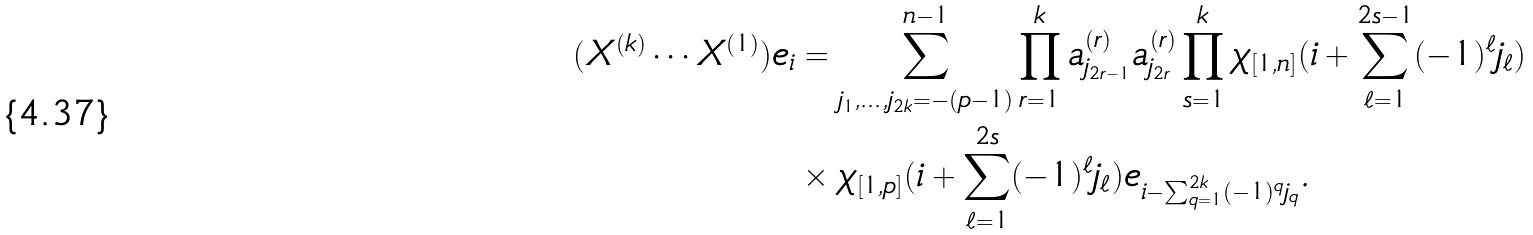<formula> <loc_0><loc_0><loc_500><loc_500>( X ^ { ( k ) } \cdots X ^ { ( 1 ) } ) e _ { i } & = \sum _ { j _ { 1 } , \dots , j _ { 2 k } = - ( p - 1 ) } ^ { n - 1 } \prod _ { r = 1 } ^ { k } a ^ { ( r ) } _ { j _ { 2 r - 1 } } a ^ { ( r ) } _ { j _ { 2 r } } \prod _ { s = 1 } ^ { k } \chi _ { [ 1 , n ] } ( i + \sum _ { \ell = 1 } ^ { 2 s - 1 } ( - 1 ) ^ { \ell } j _ { \ell } ) \\ & \times \chi _ { [ 1 , p ] } ( i + \sum _ { \ell = 1 } ^ { 2 s } ( - 1 ) ^ { \ell } j _ { \ell } ) e _ { i - \sum _ { q = 1 } ^ { 2 k } ( - 1 ) ^ { q } j _ { q } } .</formula> 